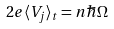<formula> <loc_0><loc_0><loc_500><loc_500>2 e \langle V _ { j } \rangle _ { t } = n \hbar { \Omega }</formula> 